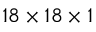Convert formula to latex. <formula><loc_0><loc_0><loc_500><loc_500>1 8 \times 1 8 \times 1</formula> 